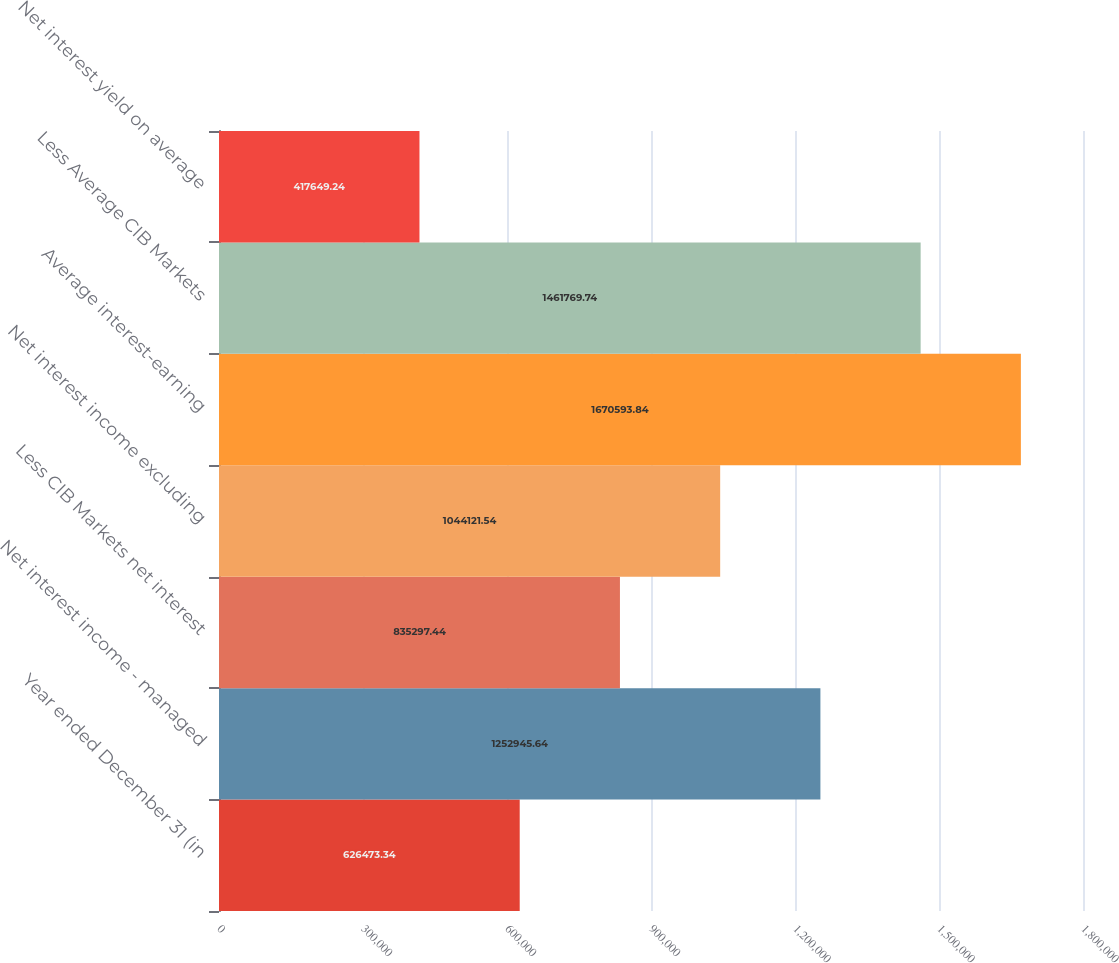<chart> <loc_0><loc_0><loc_500><loc_500><bar_chart><fcel>Year ended December 31 (in<fcel>Net interest income - managed<fcel>Less CIB Markets net interest<fcel>Net interest income excluding<fcel>Average interest-earning<fcel>Less Average CIB Markets<fcel>Net interest yield on average<nl><fcel>626473<fcel>1.25295e+06<fcel>835297<fcel>1.04412e+06<fcel>1.67059e+06<fcel>1.46177e+06<fcel>417649<nl></chart> 